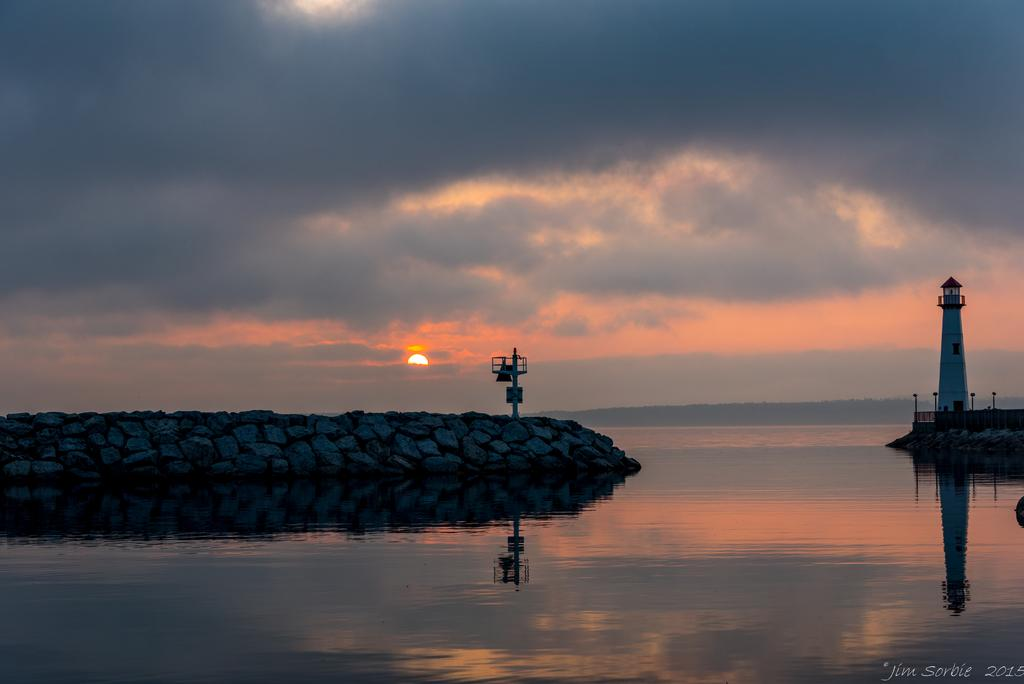What type of natural formation can be seen in the image? There are rocks in the image. What structure is present in the image? There is a lighthouse in the image. What type of barrier is visible in the image? There is fencing in the image. What vertical object can be seen in the image? There is a pole in the image. What body of water is visible in the image? There is water visible in the image. What celestial body is observable in the image? The sun is observable in the image. What part of the natural environment is visible in the image? The sky is visible in the image. What atmospheric feature can be seen in the image? There are clouds in the image. How many apples are hanging from the pole in the image? There are no apples present in the image; it features rocks, a lighthouse, fencing, a pole, water, the sun, the sky, and clouds. What is the income of the person who owns the lighthouse in the image? There is no information about the income of the person who owns the lighthouse in the image. Can you see a hand holding the rocks in the image? There is no hand holding the rocks in the image; the rocks are simply visible in the image. 